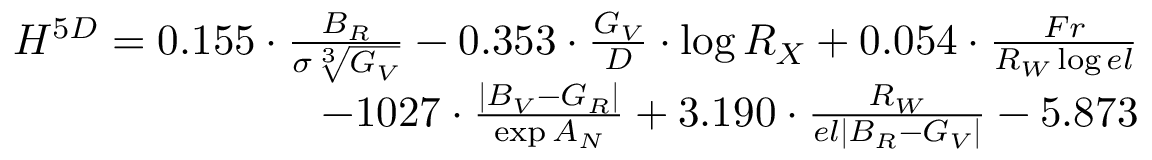Convert formula to latex. <formula><loc_0><loc_0><loc_500><loc_500>\begin{array} { r } { { H ^ { 5 D } = 0 . 1 5 5 \cdot \frac { B _ { R } } { \sigma \sqrt { [ } 3 ] { G _ { V } } } - 0 . 3 5 3 \cdot \frac { G _ { V } } { D } \cdot \log { R _ { X } } + 0 . 0 5 4 \cdot \frac { F r } { R _ { W } \log { e l } } } } \\ { { - 1 0 2 7 \cdot \frac { | B _ { V } - G _ { R } | } { \exp { A _ { N } } } + 3 . 1 9 0 \cdot \frac { R _ { W } } { e l | B _ { R } - G _ { V } | } - 5 . 8 7 3 } } \end{array}</formula> 